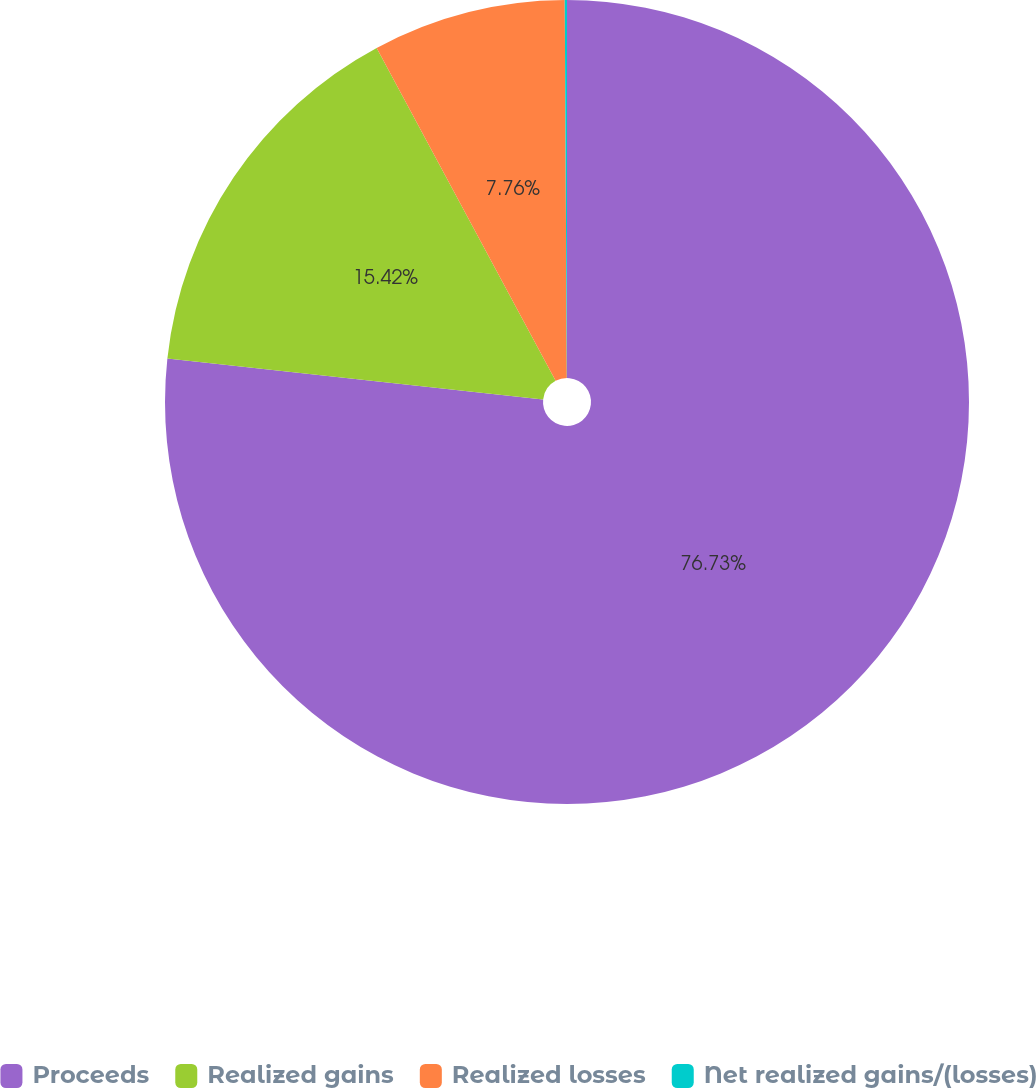Convert chart. <chart><loc_0><loc_0><loc_500><loc_500><pie_chart><fcel>Proceeds<fcel>Realized gains<fcel>Realized losses<fcel>Net realized gains/(losses)<nl><fcel>76.73%<fcel>15.42%<fcel>7.76%<fcel>0.09%<nl></chart> 